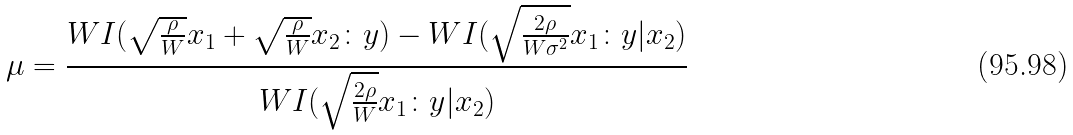Convert formula to latex. <formula><loc_0><loc_0><loc_500><loc_500>\mu = \frac { W I ( \sqrt { \frac { \rho } { W } } x _ { 1 } + \sqrt { \frac { \rho } { W } } x _ { 2 } \colon y ) - W I ( \sqrt { \frac { 2 \rho } { W \sigma ^ { 2 } } } x _ { 1 } \colon y | x _ { 2 } ) } { W I ( \sqrt { \frac { 2 \rho } { W } } x _ { 1 } \colon y | x _ { 2 } ) }</formula> 